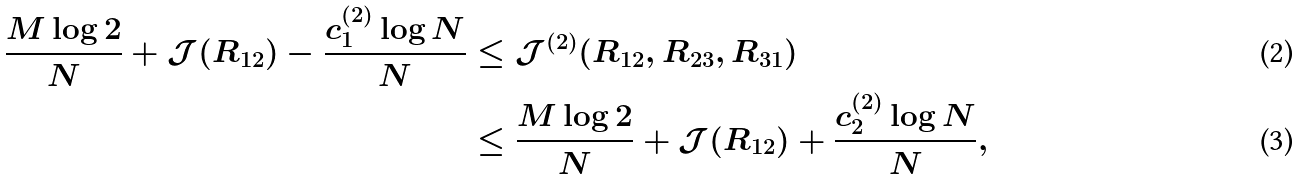Convert formula to latex. <formula><loc_0><loc_0><loc_500><loc_500>\frac { M \log 2 } { N } + \mathcal { J } ( R _ { 1 2 } ) - \frac { c _ { 1 } ^ { ( 2 ) } \log N } { N } & \leq \mathcal { J } ^ { ( 2 ) } ( R _ { 1 2 } , R _ { 2 3 } , R _ { 3 1 } ) \\ & \leq \frac { M \log 2 } { N } + \mathcal { J } ( R _ { 1 2 } ) + \frac { c _ { 2 } ^ { ( 2 ) } \log N } { N } ,</formula> 